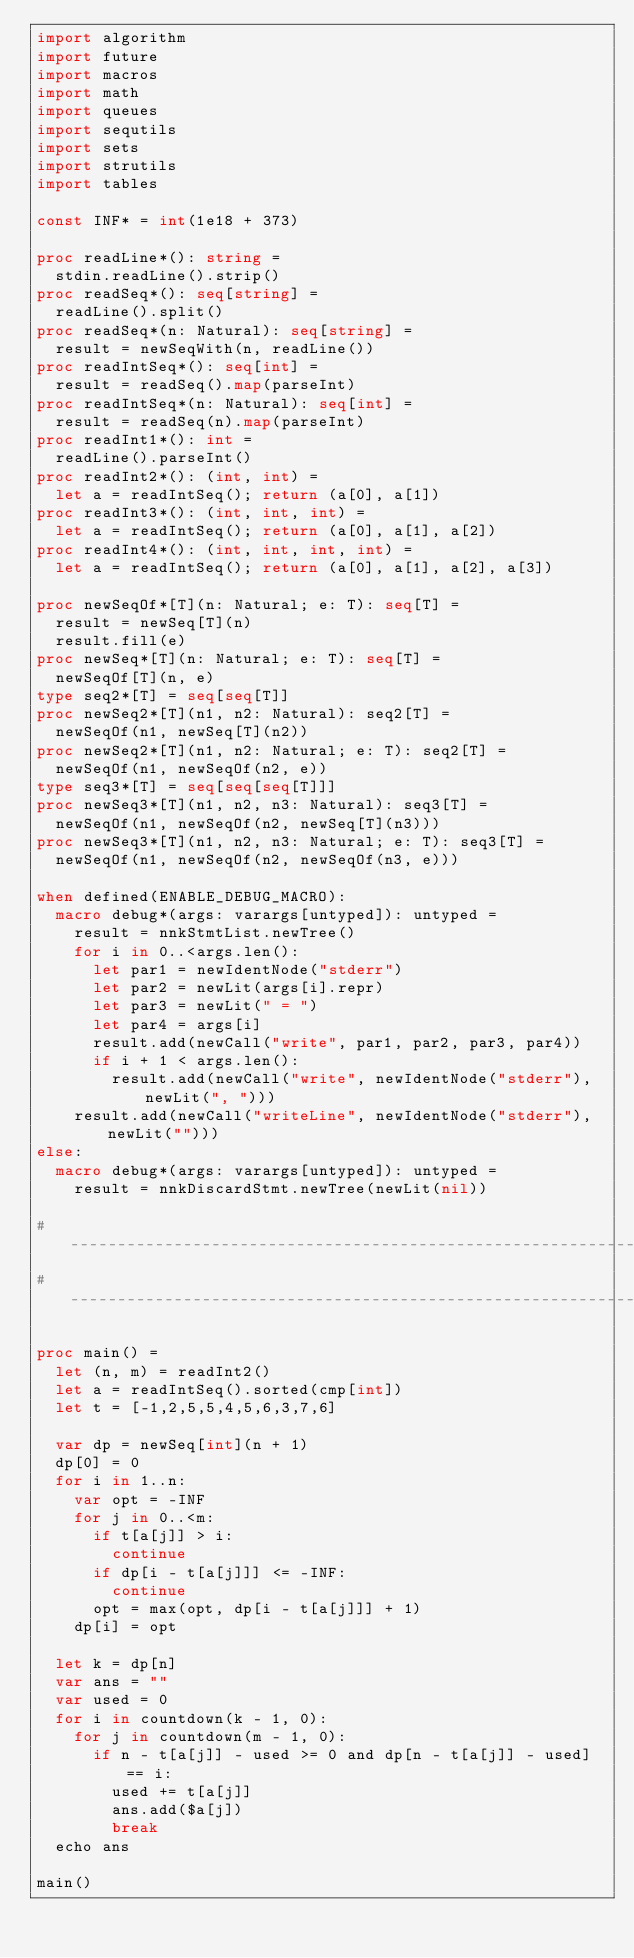<code> <loc_0><loc_0><loc_500><loc_500><_Nim_>import algorithm
import future
import macros
import math
import queues
import sequtils
import sets
import strutils
import tables

const INF* = int(1e18 + 373)

proc readLine*(): string =
  stdin.readLine().strip()
proc readSeq*(): seq[string] =
  readLine().split()
proc readSeq*(n: Natural): seq[string] =
  result = newSeqWith(n, readLine())
proc readIntSeq*(): seq[int] =
  result = readSeq().map(parseInt)
proc readIntSeq*(n: Natural): seq[int] =
  result = readSeq(n).map(parseInt)
proc readInt1*(): int =
  readLine().parseInt()
proc readInt2*(): (int, int) =
  let a = readIntSeq(); return (a[0], a[1])
proc readInt3*(): (int, int, int) =
  let a = readIntSeq(); return (a[0], a[1], a[2])
proc readInt4*(): (int, int, int, int) =
  let a = readIntSeq(); return (a[0], a[1], a[2], a[3])

proc newSeqOf*[T](n: Natural; e: T): seq[T] =
  result = newSeq[T](n)
  result.fill(e)
proc newSeq*[T](n: Natural; e: T): seq[T] =
  newSeqOf[T](n, e)
type seq2*[T] = seq[seq[T]]
proc newSeq2*[T](n1, n2: Natural): seq2[T] =
  newSeqOf(n1, newSeq[T](n2))
proc newSeq2*[T](n1, n2: Natural; e: T): seq2[T] =
  newSeqOf(n1, newSeqOf(n2, e))
type seq3*[T] = seq[seq[seq[T]]]
proc newSeq3*[T](n1, n2, n3: Natural): seq3[T] =
  newSeqOf(n1, newSeqOf(n2, newSeq[T](n3)))
proc newSeq3*[T](n1, n2, n3: Natural; e: T): seq3[T] =
  newSeqOf(n1, newSeqOf(n2, newSeqOf(n3, e)))

when defined(ENABLE_DEBUG_MACRO):
  macro debug*(args: varargs[untyped]): untyped =
    result = nnkStmtList.newTree()
    for i in 0..<args.len():
      let par1 = newIdentNode("stderr")
      let par2 = newLit(args[i].repr)
      let par3 = newLit(" = ")
      let par4 = args[i]
      result.add(newCall("write", par1, par2, par3, par4))
      if i + 1 < args.len():
        result.add(newCall("write", newIdentNode("stderr"), newLit(", ")))
    result.add(newCall("writeLine", newIdentNode("stderr"), newLit("")))
else:
  macro debug*(args: varargs[untyped]): untyped =
    result = nnkDiscardStmt.newTree(newLit(nil))

#------------------------------------------------------------------------------#
#------------------------------------------------------------------------------#

proc main() =
  let (n, m) = readInt2()
  let a = readIntSeq().sorted(cmp[int])
  let t = [-1,2,5,5,4,5,6,3,7,6]

  var dp = newSeq[int](n + 1)
  dp[0] = 0
  for i in 1..n:
    var opt = -INF
    for j in 0..<m:
      if t[a[j]] > i:
        continue
      if dp[i - t[a[j]]] <= -INF:
        continue
      opt = max(opt, dp[i - t[a[j]]] + 1)
    dp[i] = opt

  let k = dp[n]
  var ans = ""
  var used = 0
  for i in countdown(k - 1, 0):
    for j in countdown(m - 1, 0):
      if n - t[a[j]] - used >= 0 and dp[n - t[a[j]] - used] == i:
        used += t[a[j]]
        ans.add($a[j])
        break
  echo ans

main()
</code> 